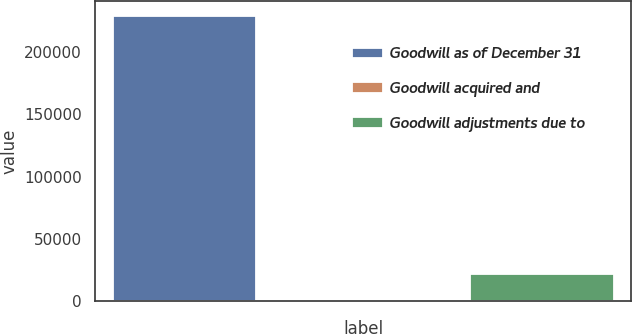Convert chart to OTSL. <chart><loc_0><loc_0><loc_500><loc_500><bar_chart><fcel>Goodwill as of December 31<fcel>Goodwill acquired and<fcel>Goodwill adjustments due to<nl><fcel>229198<fcel>1119<fcel>22085<nl></chart> 